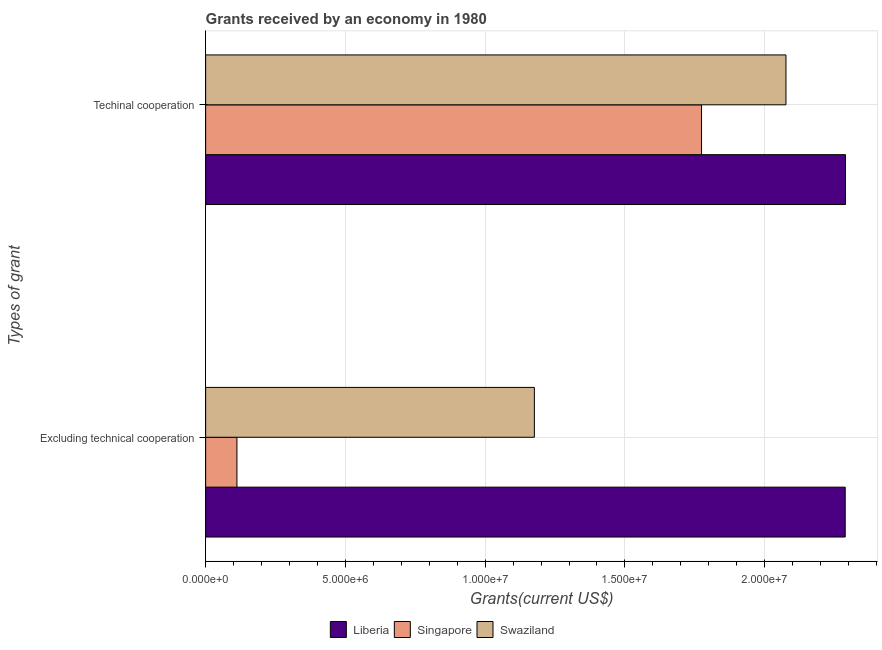How many different coloured bars are there?
Offer a terse response. 3. How many groups of bars are there?
Keep it short and to the point. 2. Are the number of bars per tick equal to the number of legend labels?
Offer a very short reply. Yes. Are the number of bars on each tick of the Y-axis equal?
Provide a short and direct response. Yes. How many bars are there on the 1st tick from the bottom?
Provide a short and direct response. 3. What is the label of the 2nd group of bars from the top?
Ensure brevity in your answer.  Excluding technical cooperation. What is the amount of grants received(excluding technical cooperation) in Swaziland?
Make the answer very short. 1.18e+07. Across all countries, what is the maximum amount of grants received(including technical cooperation)?
Provide a succinct answer. 2.29e+07. Across all countries, what is the minimum amount of grants received(excluding technical cooperation)?
Your response must be concise. 1.12e+06. In which country was the amount of grants received(including technical cooperation) maximum?
Give a very brief answer. Liberia. In which country was the amount of grants received(excluding technical cooperation) minimum?
Offer a terse response. Singapore. What is the total amount of grants received(excluding technical cooperation) in the graph?
Offer a terse response. 3.58e+07. What is the difference between the amount of grants received(including technical cooperation) in Swaziland and that in Liberia?
Give a very brief answer. -2.13e+06. What is the difference between the amount of grants received(excluding technical cooperation) in Swaziland and the amount of grants received(including technical cooperation) in Singapore?
Ensure brevity in your answer.  -5.98e+06. What is the average amount of grants received(including technical cooperation) per country?
Your response must be concise. 2.05e+07. What is the difference between the amount of grants received(including technical cooperation) and amount of grants received(excluding technical cooperation) in Swaziland?
Your response must be concise. 9.00e+06. What is the ratio of the amount of grants received(including technical cooperation) in Swaziland to that in Liberia?
Your answer should be very brief. 0.91. Is the amount of grants received(including technical cooperation) in Singapore less than that in Swaziland?
Provide a succinct answer. Yes. In how many countries, is the amount of grants received(including technical cooperation) greater than the average amount of grants received(including technical cooperation) taken over all countries?
Your response must be concise. 2. What does the 3rd bar from the top in Excluding technical cooperation represents?
Make the answer very short. Liberia. What does the 1st bar from the bottom in Techinal cooperation represents?
Ensure brevity in your answer.  Liberia. What is the difference between two consecutive major ticks on the X-axis?
Your answer should be very brief. 5.00e+06. Does the graph contain any zero values?
Offer a terse response. No. Does the graph contain grids?
Your answer should be very brief. Yes. How are the legend labels stacked?
Ensure brevity in your answer.  Horizontal. What is the title of the graph?
Keep it short and to the point. Grants received by an economy in 1980. Does "Norway" appear as one of the legend labels in the graph?
Provide a succinct answer. No. What is the label or title of the X-axis?
Offer a terse response. Grants(current US$). What is the label or title of the Y-axis?
Make the answer very short. Types of grant. What is the Grants(current US$) in Liberia in Excluding technical cooperation?
Your response must be concise. 2.29e+07. What is the Grants(current US$) in Singapore in Excluding technical cooperation?
Make the answer very short. 1.12e+06. What is the Grants(current US$) of Swaziland in Excluding technical cooperation?
Your answer should be compact. 1.18e+07. What is the Grants(current US$) in Liberia in Techinal cooperation?
Your answer should be very brief. 2.29e+07. What is the Grants(current US$) in Singapore in Techinal cooperation?
Keep it short and to the point. 1.77e+07. What is the Grants(current US$) in Swaziland in Techinal cooperation?
Make the answer very short. 2.08e+07. Across all Types of grant, what is the maximum Grants(current US$) in Liberia?
Make the answer very short. 2.29e+07. Across all Types of grant, what is the maximum Grants(current US$) of Singapore?
Give a very brief answer. 1.77e+07. Across all Types of grant, what is the maximum Grants(current US$) in Swaziland?
Offer a terse response. 2.08e+07. Across all Types of grant, what is the minimum Grants(current US$) in Liberia?
Your answer should be very brief. 2.29e+07. Across all Types of grant, what is the minimum Grants(current US$) of Singapore?
Offer a terse response. 1.12e+06. Across all Types of grant, what is the minimum Grants(current US$) of Swaziland?
Offer a terse response. 1.18e+07. What is the total Grants(current US$) in Liberia in the graph?
Ensure brevity in your answer.  4.58e+07. What is the total Grants(current US$) in Singapore in the graph?
Your answer should be very brief. 1.89e+07. What is the total Grants(current US$) in Swaziland in the graph?
Provide a succinct answer. 3.25e+07. What is the difference between the Grants(current US$) of Liberia in Excluding technical cooperation and that in Techinal cooperation?
Your answer should be compact. -10000. What is the difference between the Grants(current US$) in Singapore in Excluding technical cooperation and that in Techinal cooperation?
Offer a terse response. -1.66e+07. What is the difference between the Grants(current US$) in Swaziland in Excluding technical cooperation and that in Techinal cooperation?
Offer a very short reply. -9.00e+06. What is the difference between the Grants(current US$) of Liberia in Excluding technical cooperation and the Grants(current US$) of Singapore in Techinal cooperation?
Provide a succinct answer. 5.14e+06. What is the difference between the Grants(current US$) of Liberia in Excluding technical cooperation and the Grants(current US$) of Swaziland in Techinal cooperation?
Ensure brevity in your answer.  2.12e+06. What is the difference between the Grants(current US$) in Singapore in Excluding technical cooperation and the Grants(current US$) in Swaziland in Techinal cooperation?
Make the answer very short. -1.96e+07. What is the average Grants(current US$) in Liberia per Types of grant?
Your answer should be very brief. 2.29e+07. What is the average Grants(current US$) of Singapore per Types of grant?
Offer a very short reply. 9.43e+06. What is the average Grants(current US$) in Swaziland per Types of grant?
Offer a very short reply. 1.63e+07. What is the difference between the Grants(current US$) in Liberia and Grants(current US$) in Singapore in Excluding technical cooperation?
Your answer should be compact. 2.18e+07. What is the difference between the Grants(current US$) in Liberia and Grants(current US$) in Swaziland in Excluding technical cooperation?
Offer a very short reply. 1.11e+07. What is the difference between the Grants(current US$) of Singapore and Grants(current US$) of Swaziland in Excluding technical cooperation?
Your answer should be compact. -1.06e+07. What is the difference between the Grants(current US$) in Liberia and Grants(current US$) in Singapore in Techinal cooperation?
Provide a succinct answer. 5.15e+06. What is the difference between the Grants(current US$) of Liberia and Grants(current US$) of Swaziland in Techinal cooperation?
Provide a succinct answer. 2.13e+06. What is the difference between the Grants(current US$) of Singapore and Grants(current US$) of Swaziland in Techinal cooperation?
Make the answer very short. -3.02e+06. What is the ratio of the Grants(current US$) of Liberia in Excluding technical cooperation to that in Techinal cooperation?
Provide a succinct answer. 1. What is the ratio of the Grants(current US$) of Singapore in Excluding technical cooperation to that in Techinal cooperation?
Make the answer very short. 0.06. What is the ratio of the Grants(current US$) of Swaziland in Excluding technical cooperation to that in Techinal cooperation?
Keep it short and to the point. 0.57. What is the difference between the highest and the second highest Grants(current US$) in Liberia?
Provide a short and direct response. 10000. What is the difference between the highest and the second highest Grants(current US$) in Singapore?
Your response must be concise. 1.66e+07. What is the difference between the highest and the second highest Grants(current US$) of Swaziland?
Make the answer very short. 9.00e+06. What is the difference between the highest and the lowest Grants(current US$) in Singapore?
Offer a terse response. 1.66e+07. What is the difference between the highest and the lowest Grants(current US$) of Swaziland?
Your answer should be compact. 9.00e+06. 